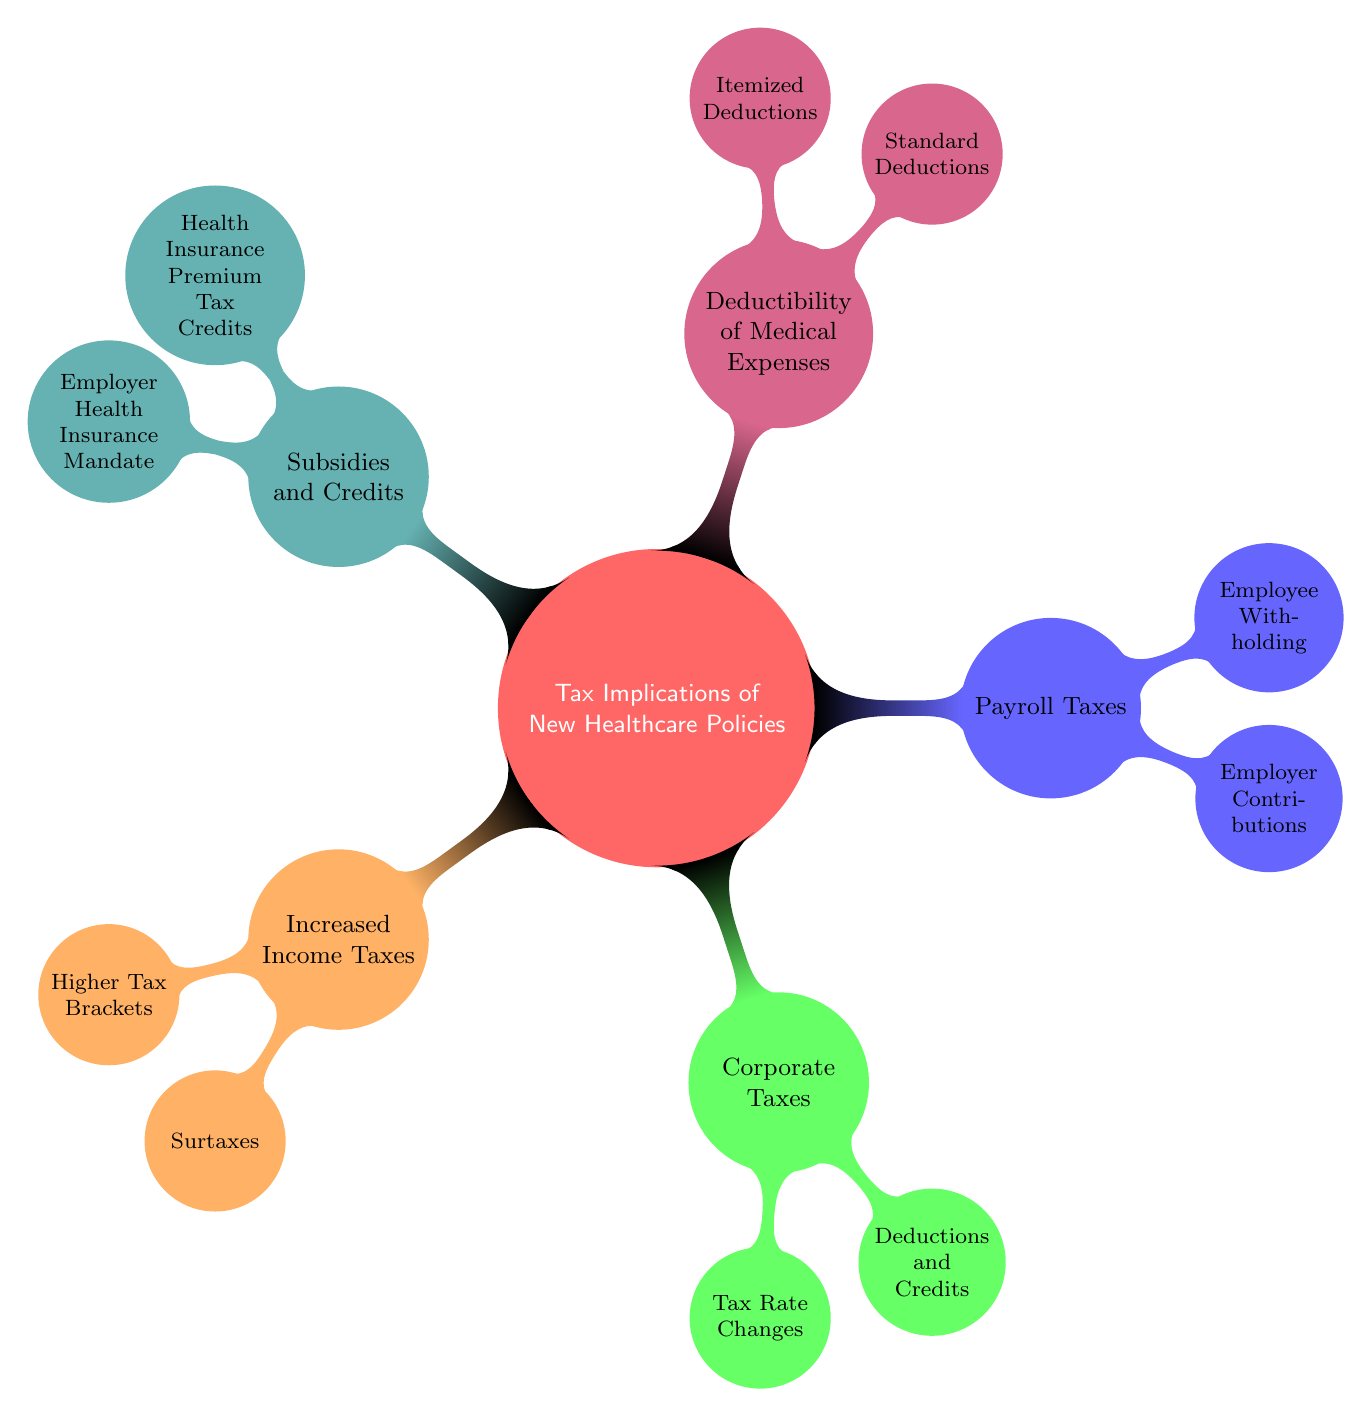What are the two main categories of tax implications in the diagram? The main categories listed in the diagram are "Increased Income Taxes" and "Corporate Taxes". These are two of the five key nodes directly connected to the main topic.
Answer: Increased Income Taxes, Corporate Taxes How many sub-nodes are under Payroll Taxes? Under the "Payroll Taxes" category, there are two sub-nodes: "Employer Contributions" and "Employee Withholding". This can be counted directly from the diagram.
Answer: 2 Which sub-node discusses adjustments in income tax? The sub-node that discusses adjustments in income tax is "Higher Tax Brackets", which is under the "Increased Income Taxes" category. It's explicitly connected to the main topic.
Answer: Higher Tax Brackets What is the focus of the sub-node under Subsidies and Credits? The sub-node under "Subsidies and Credits" focuses on "Health Insurance Premium Tax Credits", which relates to tax credits associated with health insurance premiums.
Answer: Health Insurance Premium Tax Credits What relationship exists between "Corporate Taxes" and "Deductions and Credits"? "Deductions and Credits" is a sub-node under "Corporate Taxes", indicating that it is an aspect of corporate taxation and refers to how existing deductions and credits may be affected.
Answer: Sub-node relationship How do Increased Income Taxes potentially affect high-income taxpayers specifically? The potential creation of new tax brackets, mentioned in the sub-node "Higher Tax Brackets", specifically indicates that high-income taxpayers could face higher taxes.
Answer: Higher tax brackets Which sub-node indicates changes regarding medical expense deductions? The sub-node that indicates changes regarding medical expense deductions is "Itemized Deductions", which is under the "Deductibility of Medical Expenses" category.
Answer: Itemized Deductions What type of taxes is affected by increased employer contributions? The increased employer contributions affect "Payroll Taxes", as indicated by the specific sub-node relating to this tax category.
Answer: Payroll Taxes 